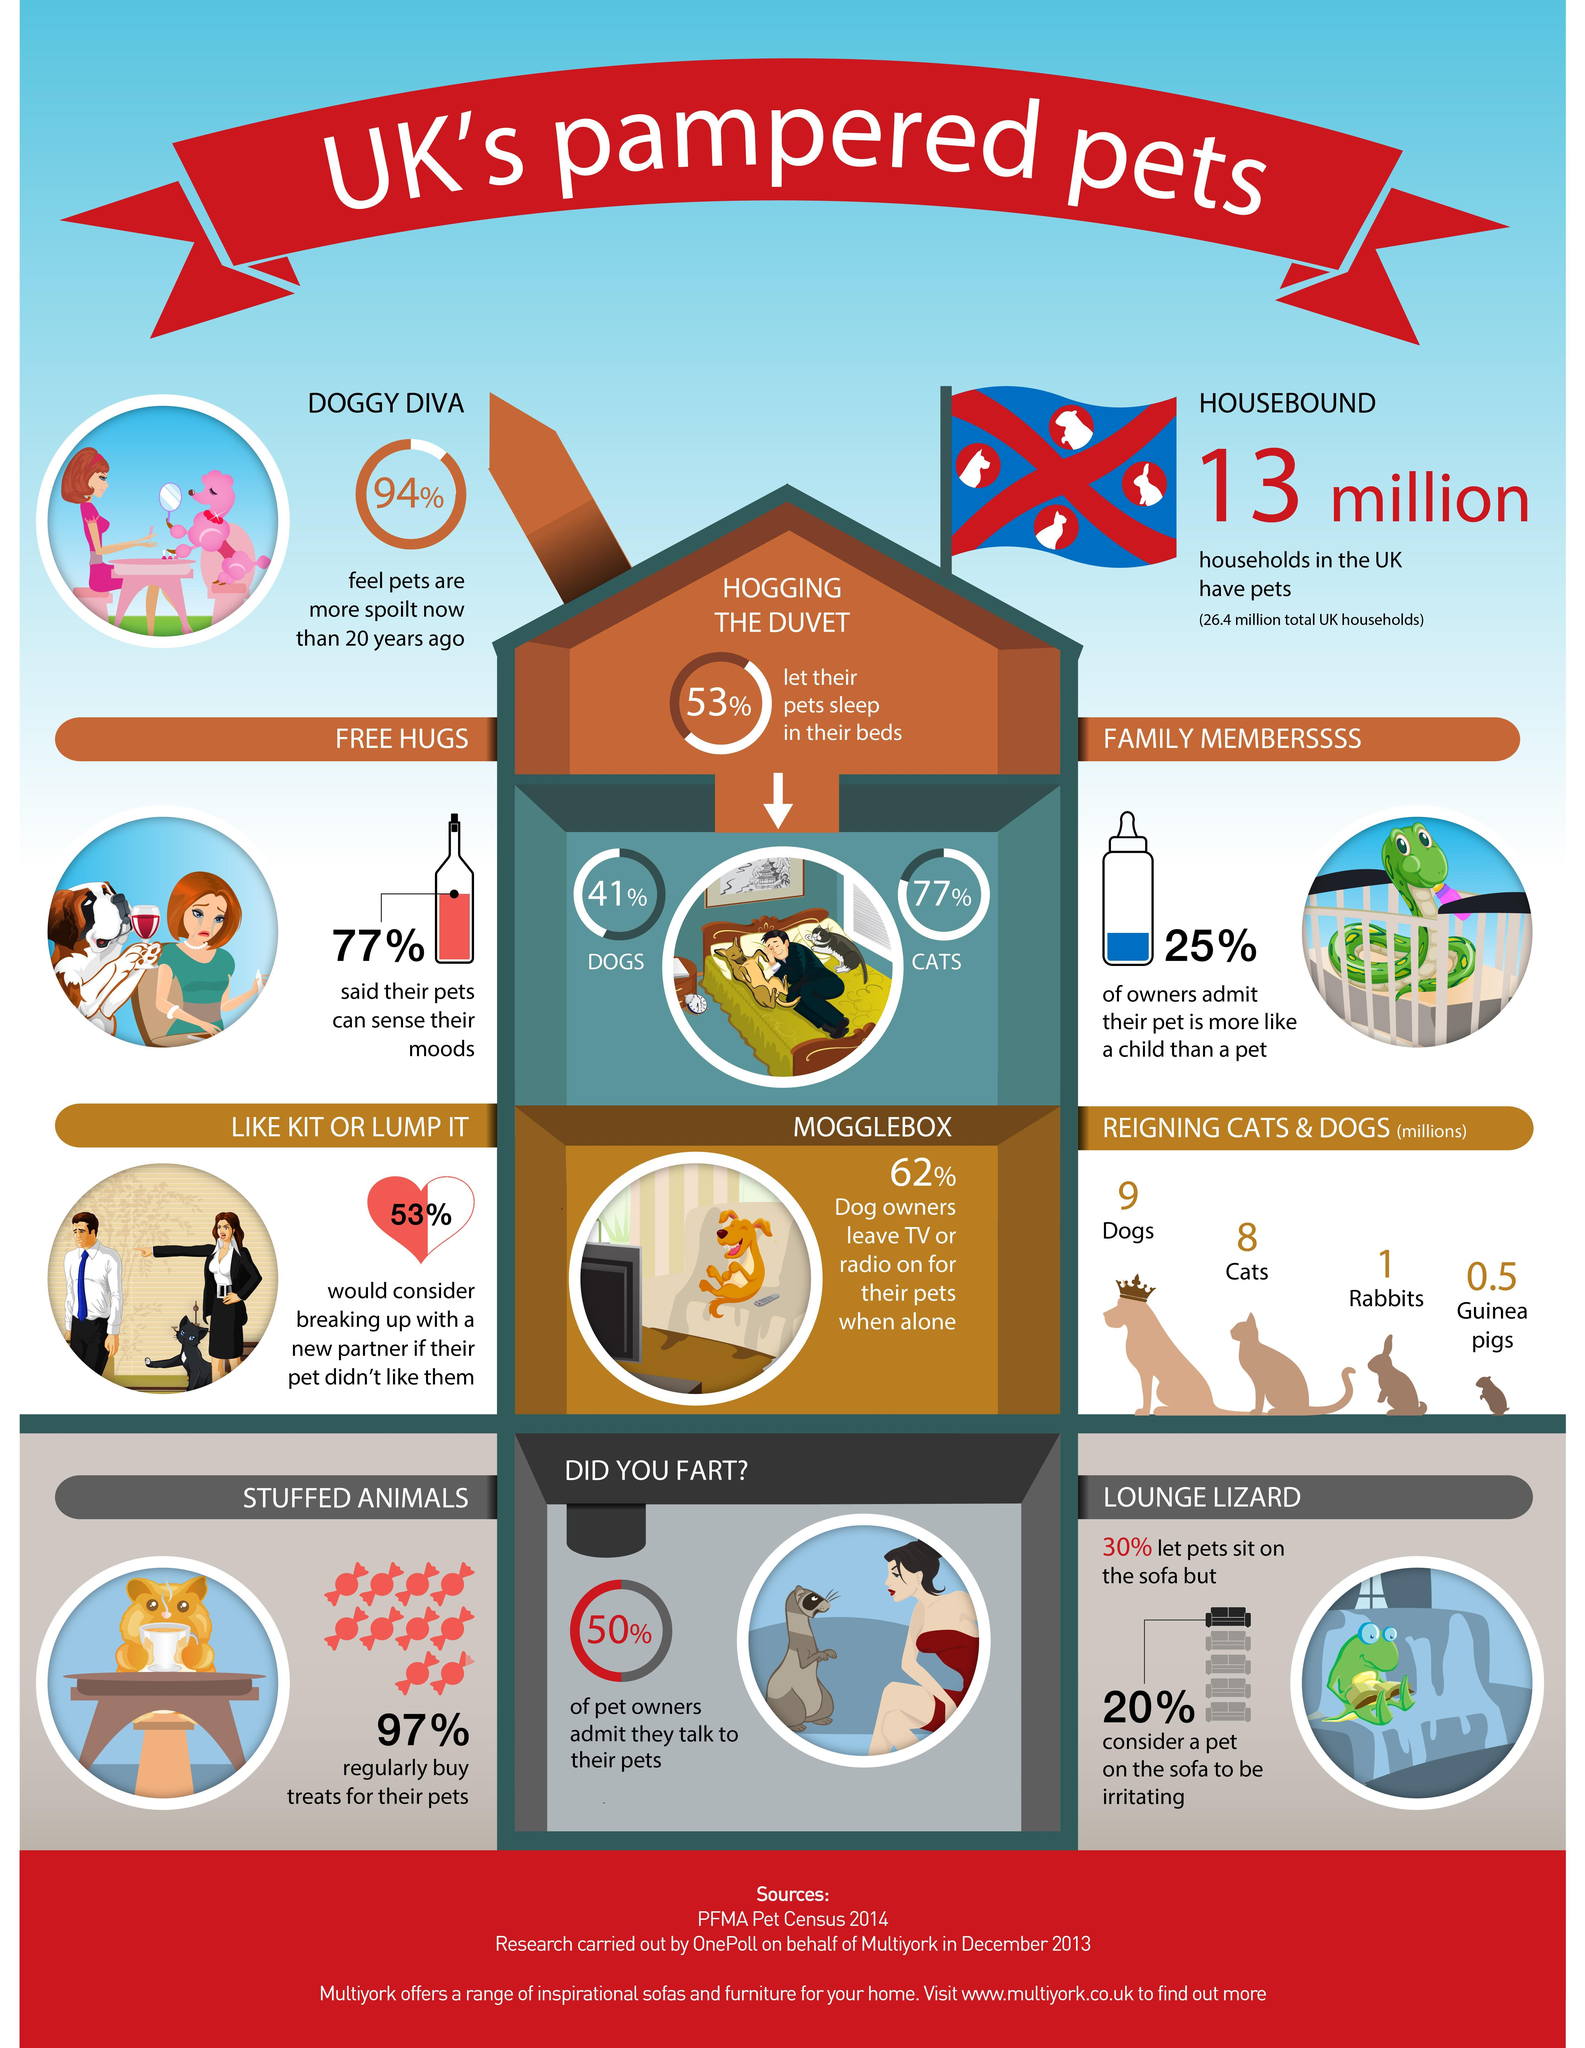What is the number of reigning dogs (in millions) in UK?
Answer the question with a short phrase. 9 What percent of pet owners in UK do not buy treats for their pets regularly? 3% What percent of pet owners in UK admit that they don't talk to their pets? 50% What percentage of owners in UK said their pets can sense their moods? 77% What percentage of owners in UK admit that their pet is more like a child than a pet? 25% What is the number of reigning cats (in millions) in UK? 8 